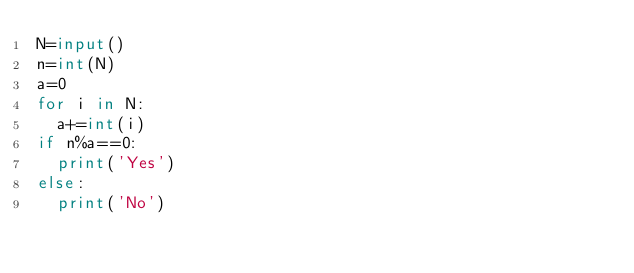Convert code to text. <code><loc_0><loc_0><loc_500><loc_500><_Python_>N=input()
n=int(N)
a=0
for i in N:
  a+=int(i)
if n%a==0:
  print('Yes')
else:
  print('No')
</code> 